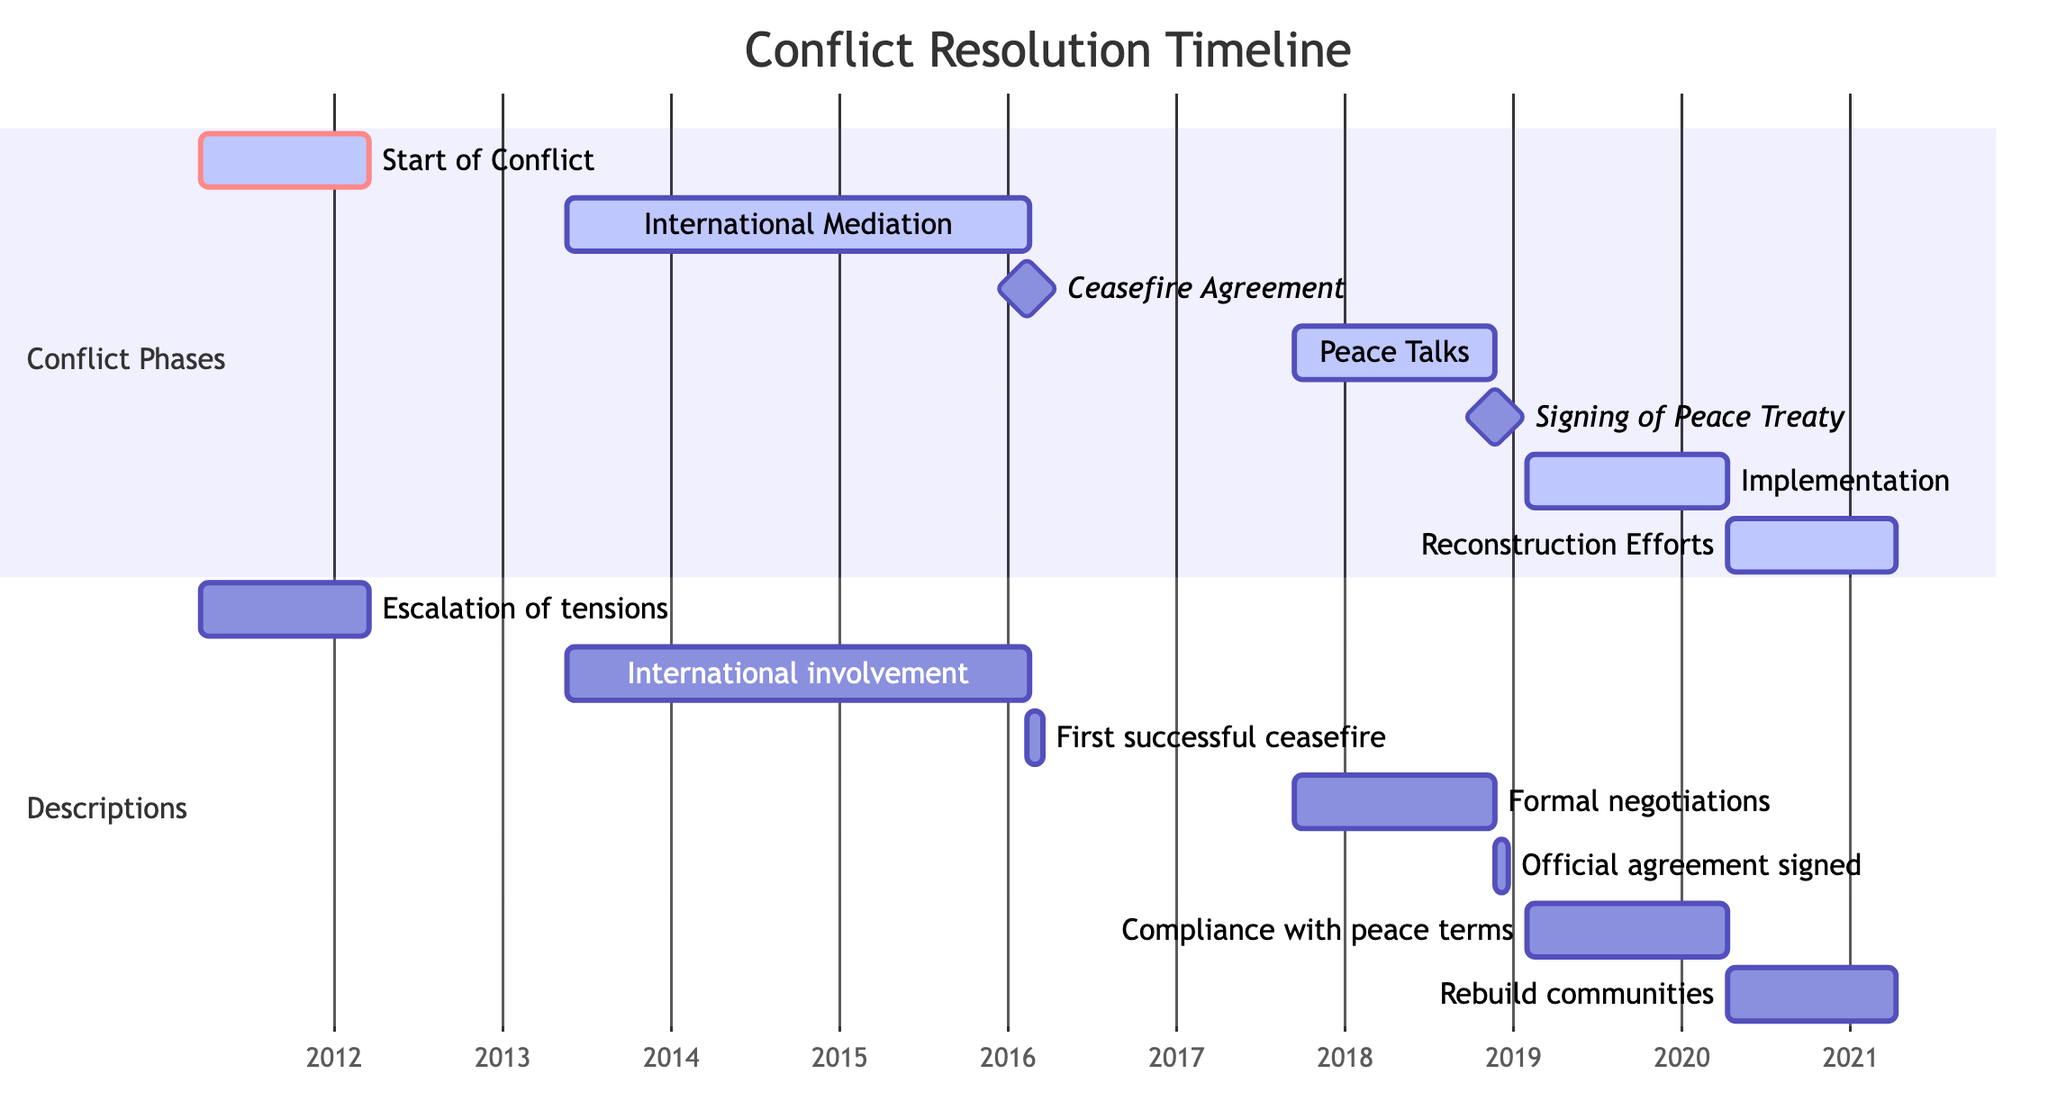What event started the conflict? The diagram shows the first event on the timeline labeled "Start of Conflict," which occurred on March 15, 2011.
Answer: Start of Conflict How long did the International Mediation take? By looking at the timeline, the International Mediation event started on May 20, 2013, and lasted until it was completed, not specified in the Gantt chart but extending to a duration of 1000 days.
Answer: 1000 days What is the significance of February 12, 2016, in the diagram? This date marks the "Ceasefire Agreement," which is indicated as a milestone event in the Gantt chart. It is a crucial point as it represents a successful ceasefire signed by opposing parties.
Answer: Ceasefire Agreement How many milestones are represented in the Gantt Chart? There are two events marked as milestones in the diagram: "Ceasefire Agreement" and "Signing of Peace Treaty," thus indicating a total of two milestones.
Answer: 2 What was the duration of the Implementation phase? The "Implementation of Peace Agreement" event lasted from January 30, 2019, for 436 days, which can be confirmed by checking the duration noted in the Gantt chart.
Answer: 436 days When did Reconstruction Efforts begin? The "Reconstruction Efforts" is marked to begin on April 10, 2020, according to the timeline in the diagram.
Answer: April 10, 2020 Which two events occurred after the Signing of Peace Treaty? The "Implementation of Peace Agreement" began immediately after the "Signing of Peace Treaty," followed by "Reconstruction Efforts." This can be derived from the sequential flow shown in the Gantt chart.
Answer: Implementation of Peace Agreement, Reconstruction Efforts What does the color indicate for the 'Start of Conflict' event? The 'Start of Conflict' event is colored red and marked as critical, which signifies that this event is significant in the timeline.
Answer: Critical What is the longest phase in this timeline? The Gantt chart indicates that the "International Mediation" took 1000 days, making it the longest phase based on the duration specified for each event.
Answer: International Mediation 